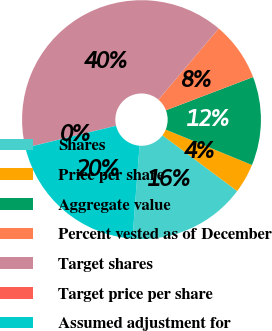Convert chart. <chart><loc_0><loc_0><loc_500><loc_500><pie_chart><fcel>Shares<fcel>Price per share<fcel>Aggregate value<fcel>Percent vested as of December<fcel>Target shares<fcel>Target price per share<fcel>Assumed adjustment for<nl><fcel>16.0%<fcel>4.01%<fcel>12.0%<fcel>8.01%<fcel>39.98%<fcel>0.01%<fcel>20.0%<nl></chart> 